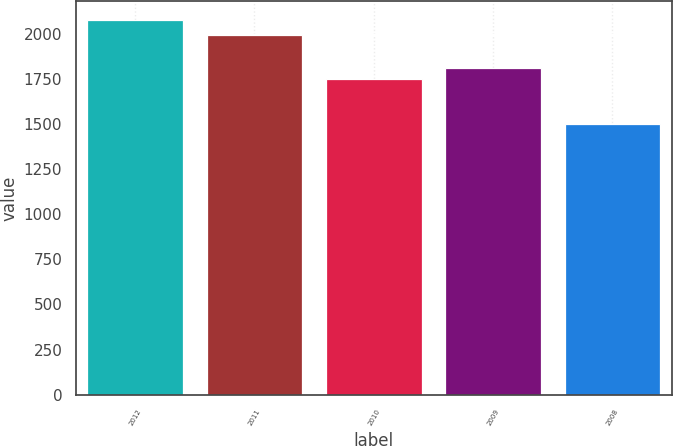Convert chart to OTSL. <chart><loc_0><loc_0><loc_500><loc_500><bar_chart><fcel>2012<fcel>2011<fcel>2010<fcel>2009<fcel>2008<nl><fcel>2077<fcel>1992<fcel>1752<fcel>1809.4<fcel>1503<nl></chart> 